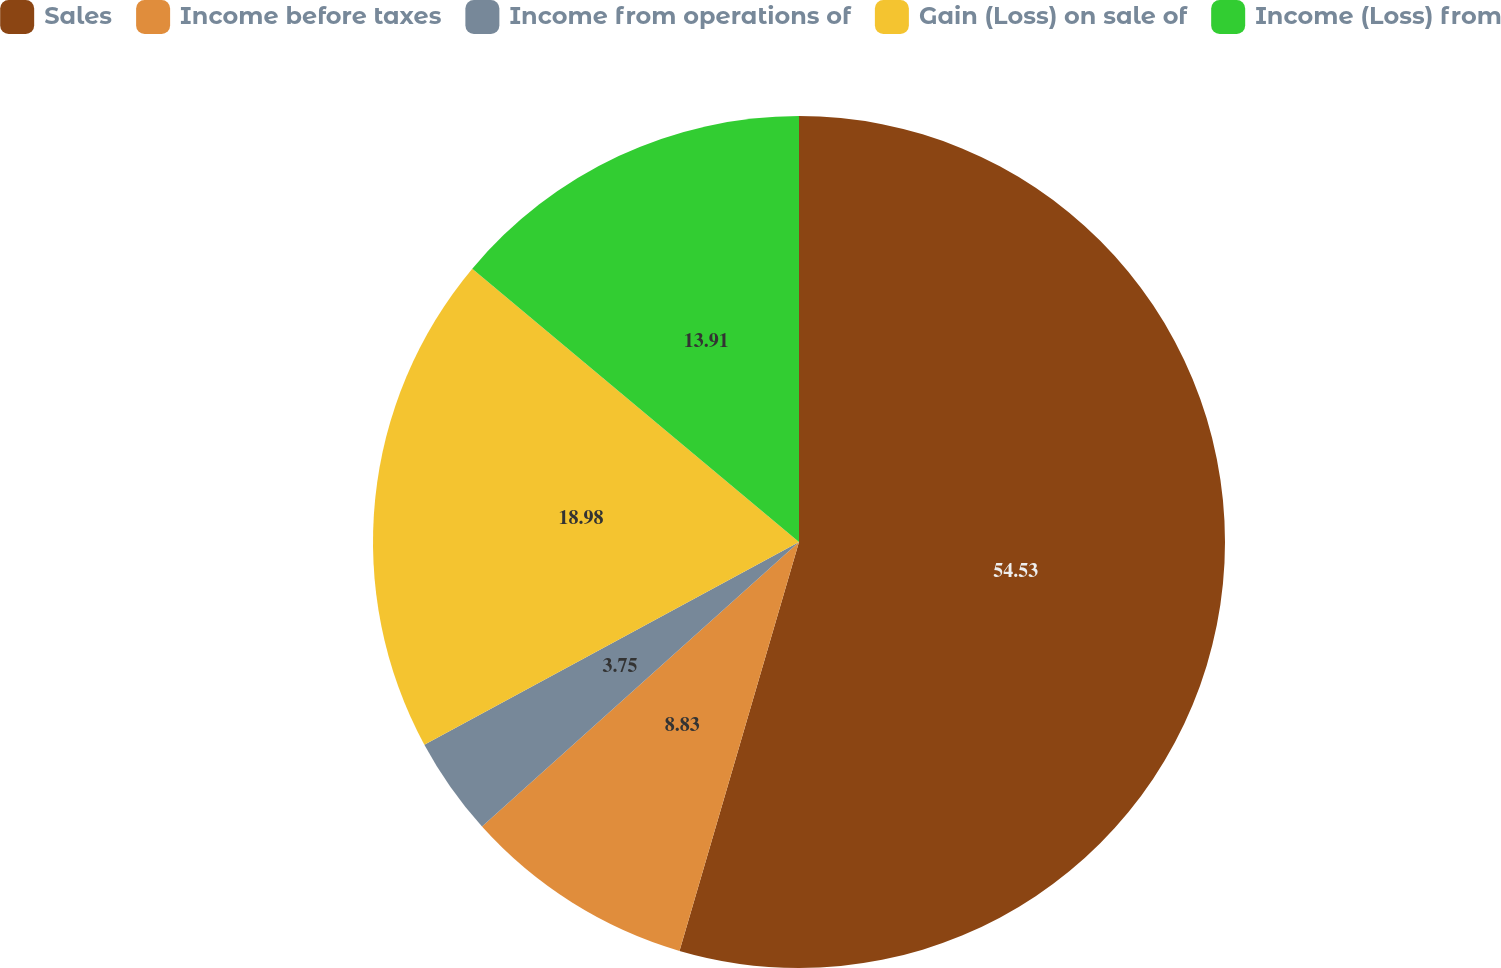<chart> <loc_0><loc_0><loc_500><loc_500><pie_chart><fcel>Sales<fcel>Income before taxes<fcel>Income from operations of<fcel>Gain (Loss) on sale of<fcel>Income (Loss) from<nl><fcel>54.52%<fcel>8.83%<fcel>3.75%<fcel>18.98%<fcel>13.91%<nl></chart> 